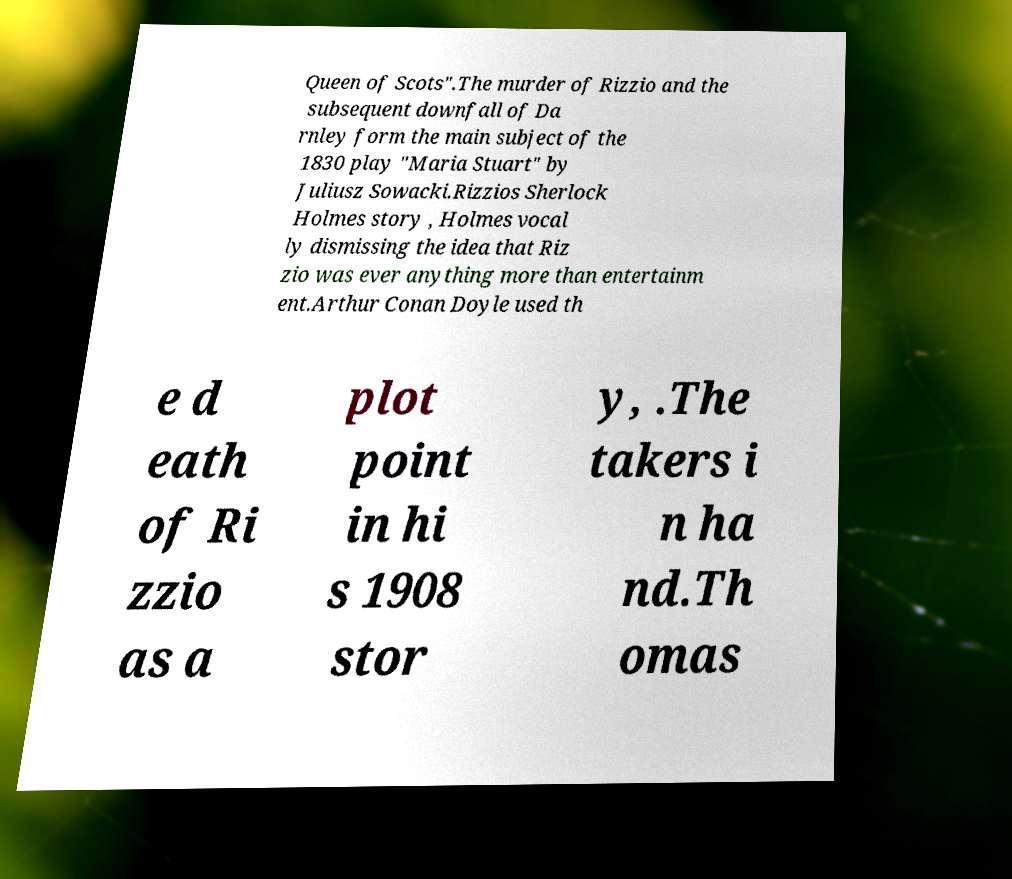What messages or text are displayed in this image? I need them in a readable, typed format. Queen of Scots".The murder of Rizzio and the subsequent downfall of Da rnley form the main subject of the 1830 play "Maria Stuart" by Juliusz Sowacki.Rizzios Sherlock Holmes story , Holmes vocal ly dismissing the idea that Riz zio was ever anything more than entertainm ent.Arthur Conan Doyle used th e d eath of Ri zzio as a plot point in hi s 1908 stor y, .The takers i n ha nd.Th omas 